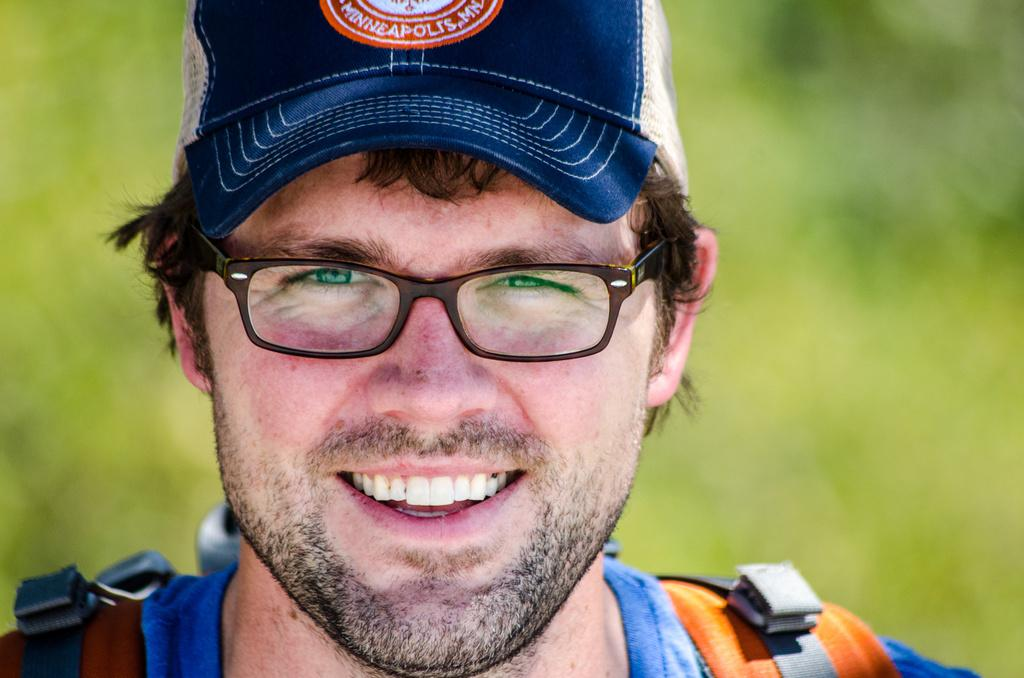Who is present in the image? There is a man in the image. What is the man wearing on his head? The man is wearing a cap on his head. What accessory is the man wearing on his face? The man is wearing spectacles. What is the man's facial expression? The man is smiling. What is the man looking at in the image? The man is looking at a picture. How would you describe the background of the image? The background of the image is blurred. How many oranges are being crushed by the man in the image? There are no oranges or any indication of crushing in the image. 